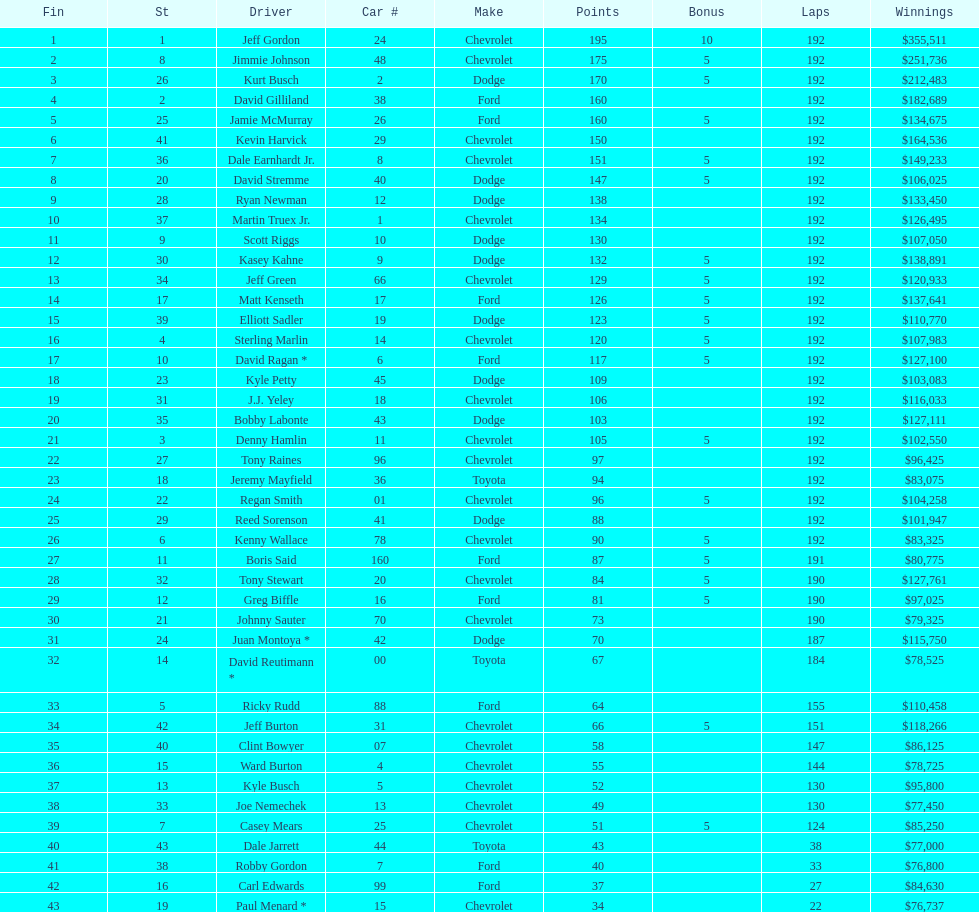Who got the most bonus points? Jeff Gordon. I'm looking to parse the entire table for insights. Could you assist me with that? {'header': ['Fin', 'St', 'Driver', 'Car #', 'Make', 'Points', 'Bonus', 'Laps', 'Winnings'], 'rows': [['1', '1', 'Jeff Gordon', '24', 'Chevrolet', '195', '10', '192', '$355,511'], ['2', '8', 'Jimmie Johnson', '48', 'Chevrolet', '175', '5', '192', '$251,736'], ['3', '26', 'Kurt Busch', '2', 'Dodge', '170', '5', '192', '$212,483'], ['4', '2', 'David Gilliland', '38', 'Ford', '160', '', '192', '$182,689'], ['5', '25', 'Jamie McMurray', '26', 'Ford', '160', '5', '192', '$134,675'], ['6', '41', 'Kevin Harvick', '29', 'Chevrolet', '150', '', '192', '$164,536'], ['7', '36', 'Dale Earnhardt Jr.', '8', 'Chevrolet', '151', '5', '192', '$149,233'], ['8', '20', 'David Stremme', '40', 'Dodge', '147', '5', '192', '$106,025'], ['9', '28', 'Ryan Newman', '12', 'Dodge', '138', '', '192', '$133,450'], ['10', '37', 'Martin Truex Jr.', '1', 'Chevrolet', '134', '', '192', '$126,495'], ['11', '9', 'Scott Riggs', '10', 'Dodge', '130', '', '192', '$107,050'], ['12', '30', 'Kasey Kahne', '9', 'Dodge', '132', '5', '192', '$138,891'], ['13', '34', 'Jeff Green', '66', 'Chevrolet', '129', '5', '192', '$120,933'], ['14', '17', 'Matt Kenseth', '17', 'Ford', '126', '5', '192', '$137,641'], ['15', '39', 'Elliott Sadler', '19', 'Dodge', '123', '5', '192', '$110,770'], ['16', '4', 'Sterling Marlin', '14', 'Chevrolet', '120', '5', '192', '$107,983'], ['17', '10', 'David Ragan *', '6', 'Ford', '117', '5', '192', '$127,100'], ['18', '23', 'Kyle Petty', '45', 'Dodge', '109', '', '192', '$103,083'], ['19', '31', 'J.J. Yeley', '18', 'Chevrolet', '106', '', '192', '$116,033'], ['20', '35', 'Bobby Labonte', '43', 'Dodge', '103', '', '192', '$127,111'], ['21', '3', 'Denny Hamlin', '11', 'Chevrolet', '105', '5', '192', '$102,550'], ['22', '27', 'Tony Raines', '96', 'Chevrolet', '97', '', '192', '$96,425'], ['23', '18', 'Jeremy Mayfield', '36', 'Toyota', '94', '', '192', '$83,075'], ['24', '22', 'Regan Smith', '01', 'Chevrolet', '96', '5', '192', '$104,258'], ['25', '29', 'Reed Sorenson', '41', 'Dodge', '88', '', '192', '$101,947'], ['26', '6', 'Kenny Wallace', '78', 'Chevrolet', '90', '5', '192', '$83,325'], ['27', '11', 'Boris Said', '160', 'Ford', '87', '5', '191', '$80,775'], ['28', '32', 'Tony Stewart', '20', 'Chevrolet', '84', '5', '190', '$127,761'], ['29', '12', 'Greg Biffle', '16', 'Ford', '81', '5', '190', '$97,025'], ['30', '21', 'Johnny Sauter', '70', 'Chevrolet', '73', '', '190', '$79,325'], ['31', '24', 'Juan Montoya *', '42', 'Dodge', '70', '', '187', '$115,750'], ['32', '14', 'David Reutimann *', '00', 'Toyota', '67', '', '184', '$78,525'], ['33', '5', 'Ricky Rudd', '88', 'Ford', '64', '', '155', '$110,458'], ['34', '42', 'Jeff Burton', '31', 'Chevrolet', '66', '5', '151', '$118,266'], ['35', '40', 'Clint Bowyer', '07', 'Chevrolet', '58', '', '147', '$86,125'], ['36', '15', 'Ward Burton', '4', 'Chevrolet', '55', '', '144', '$78,725'], ['37', '13', 'Kyle Busch', '5', 'Chevrolet', '52', '', '130', '$95,800'], ['38', '33', 'Joe Nemechek', '13', 'Chevrolet', '49', '', '130', '$77,450'], ['39', '7', 'Casey Mears', '25', 'Chevrolet', '51', '5', '124', '$85,250'], ['40', '43', 'Dale Jarrett', '44', 'Toyota', '43', '', '38', '$77,000'], ['41', '38', 'Robby Gordon', '7', 'Ford', '40', '', '33', '$76,800'], ['42', '16', 'Carl Edwards', '99', 'Ford', '37', '', '27', '$84,630'], ['43', '19', 'Paul Menard *', '15', 'Chevrolet', '34', '', '22', '$76,737']]} 